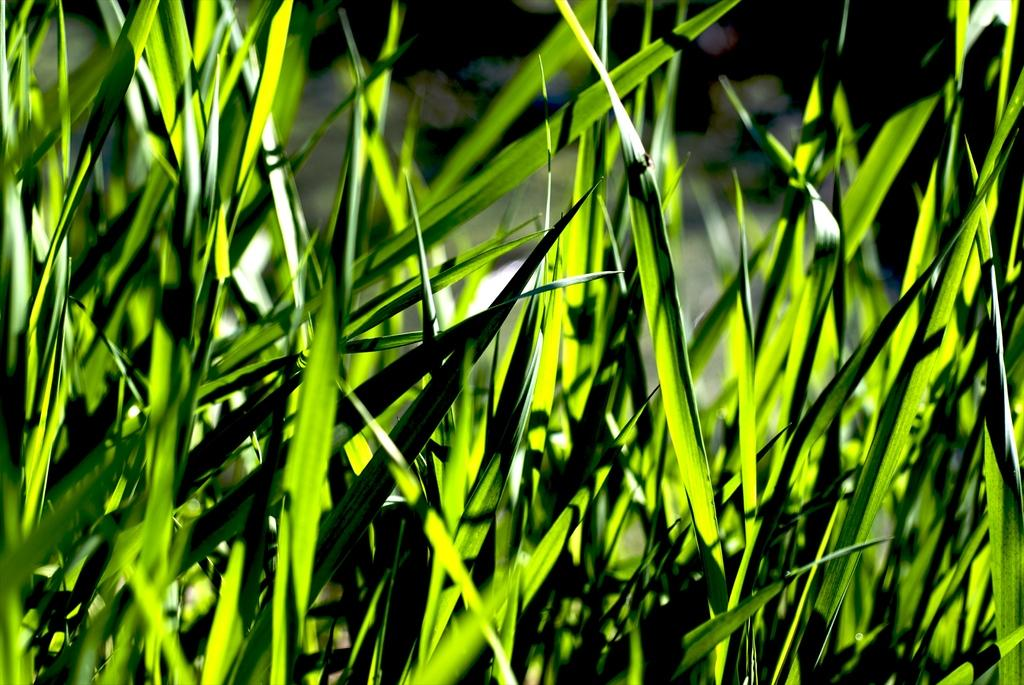What type of living organisms can be seen in the image? Plants can be seen in the image. What color are the leaves of the plants in the image? The leaves of the plants in the image are green. Can you describe the background of the image? The background of the image is blurred. What type of beam is holding up the coach in the image? There is no coach or beam present in the image; it only features plants with green leaves and a blurred background. 